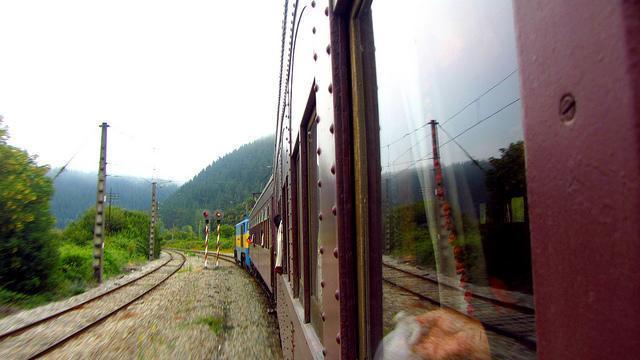Why is the train stopped?
Make your selection and explain in format: 'Answer: answer
Rationale: rationale.'
Options: No fuel, broken, red light, abandoned. Answer: red light.
Rationale: The train is waiting for the green light. 